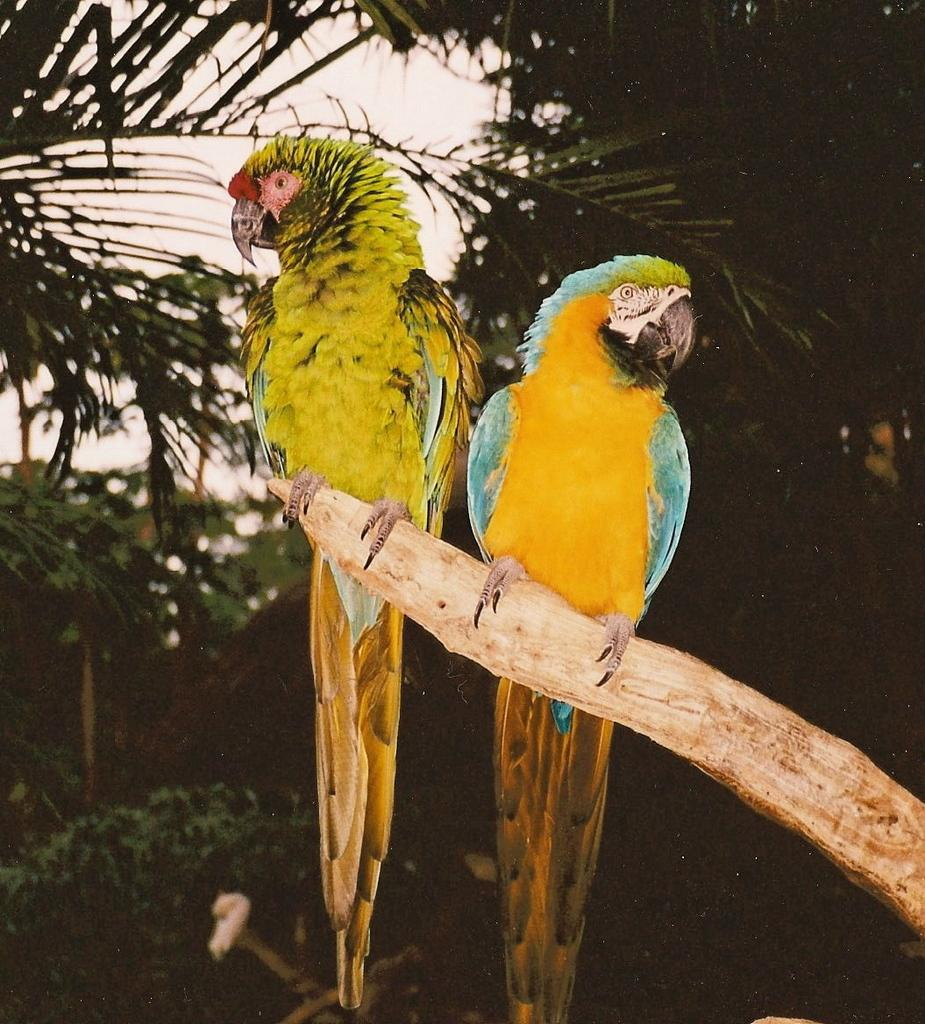What animals are in the foreground of the picture? There are two parrots in the foreground of the picture. What are the parrots sitting on? The parrots are sitting on a stem. What can be seen in the background of the picture? There are trees, a plant, and the sky visible in the background of the picture. How many feet are visible in the image? There are no feet visible in the image; it features two parrots sitting on a stem. What type of clover is growing near the parrots in the image? There is no clover present in the image; it features trees and a plant in the background. 